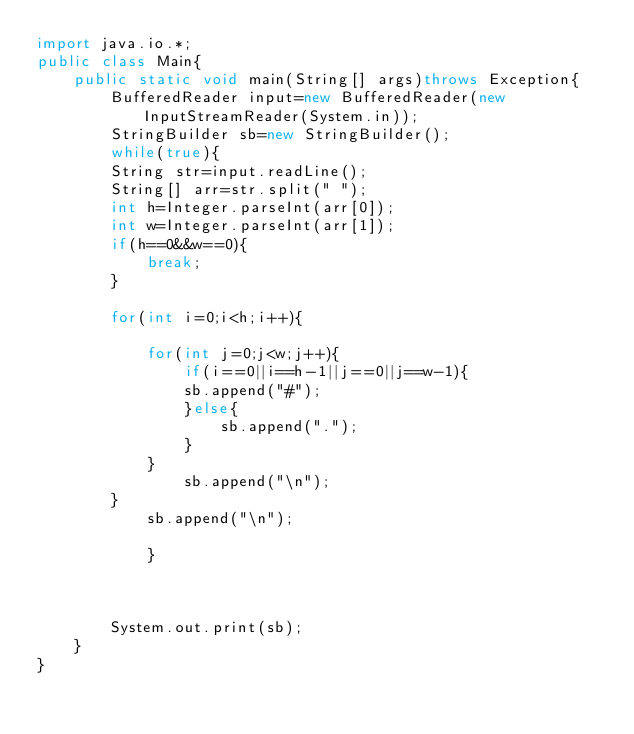<code> <loc_0><loc_0><loc_500><loc_500><_Java_>import java.io.*;
public class Main{
	public static void main(String[] args)throws Exception{
		BufferedReader input=new BufferedReader(new InputStreamReader(System.in));
		StringBuilder sb=new StringBuilder();
		while(true){
		String str=input.readLine();
		String[] arr=str.split(" ");
		int h=Integer.parseInt(arr[0]);	
		int w=Integer.parseInt(arr[1]);
		if(h==0&&w==0){
			break;
		}
	
		for(int i=0;i<h;i++){

			for(int j=0;j<w;j++){
				if(i==0||i==h-1||j==0||j==w-1){
				sb.append("#");
				}else{
					sb.append(".");
				}
			}
				sb.append("\n");
		}
			sb.append("\n");

			}
		
		
		
		System.out.print(sb);
	}
}</code> 